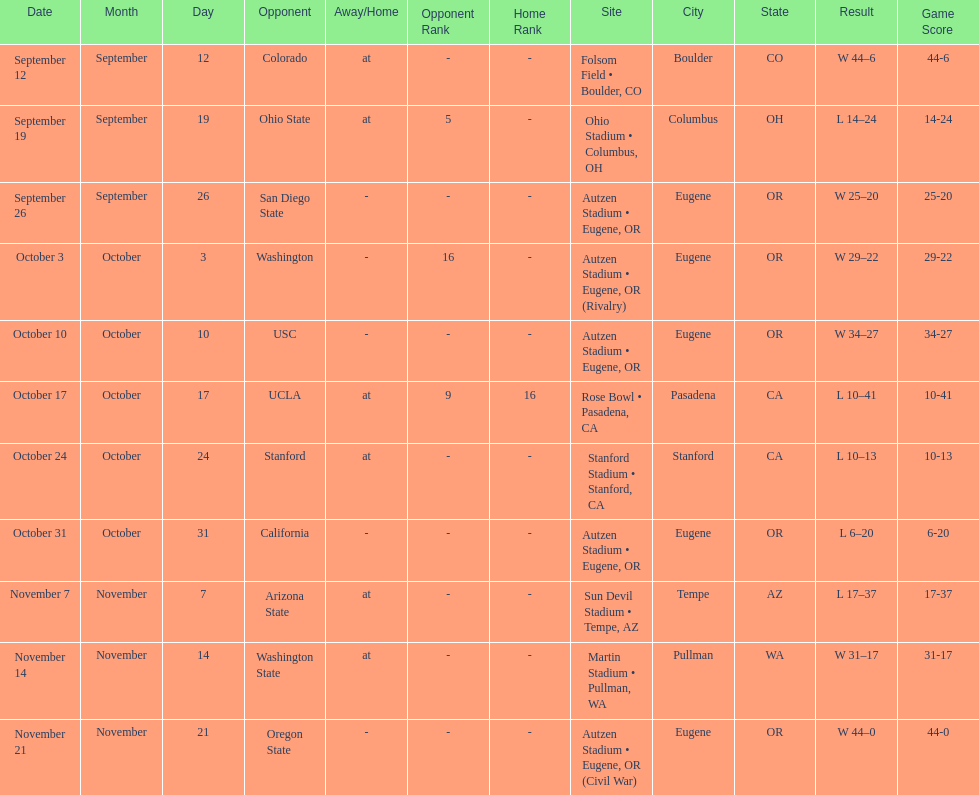Which bowl game did the university of oregon ducks football team play in during the 1987 season? Rose Bowl. 